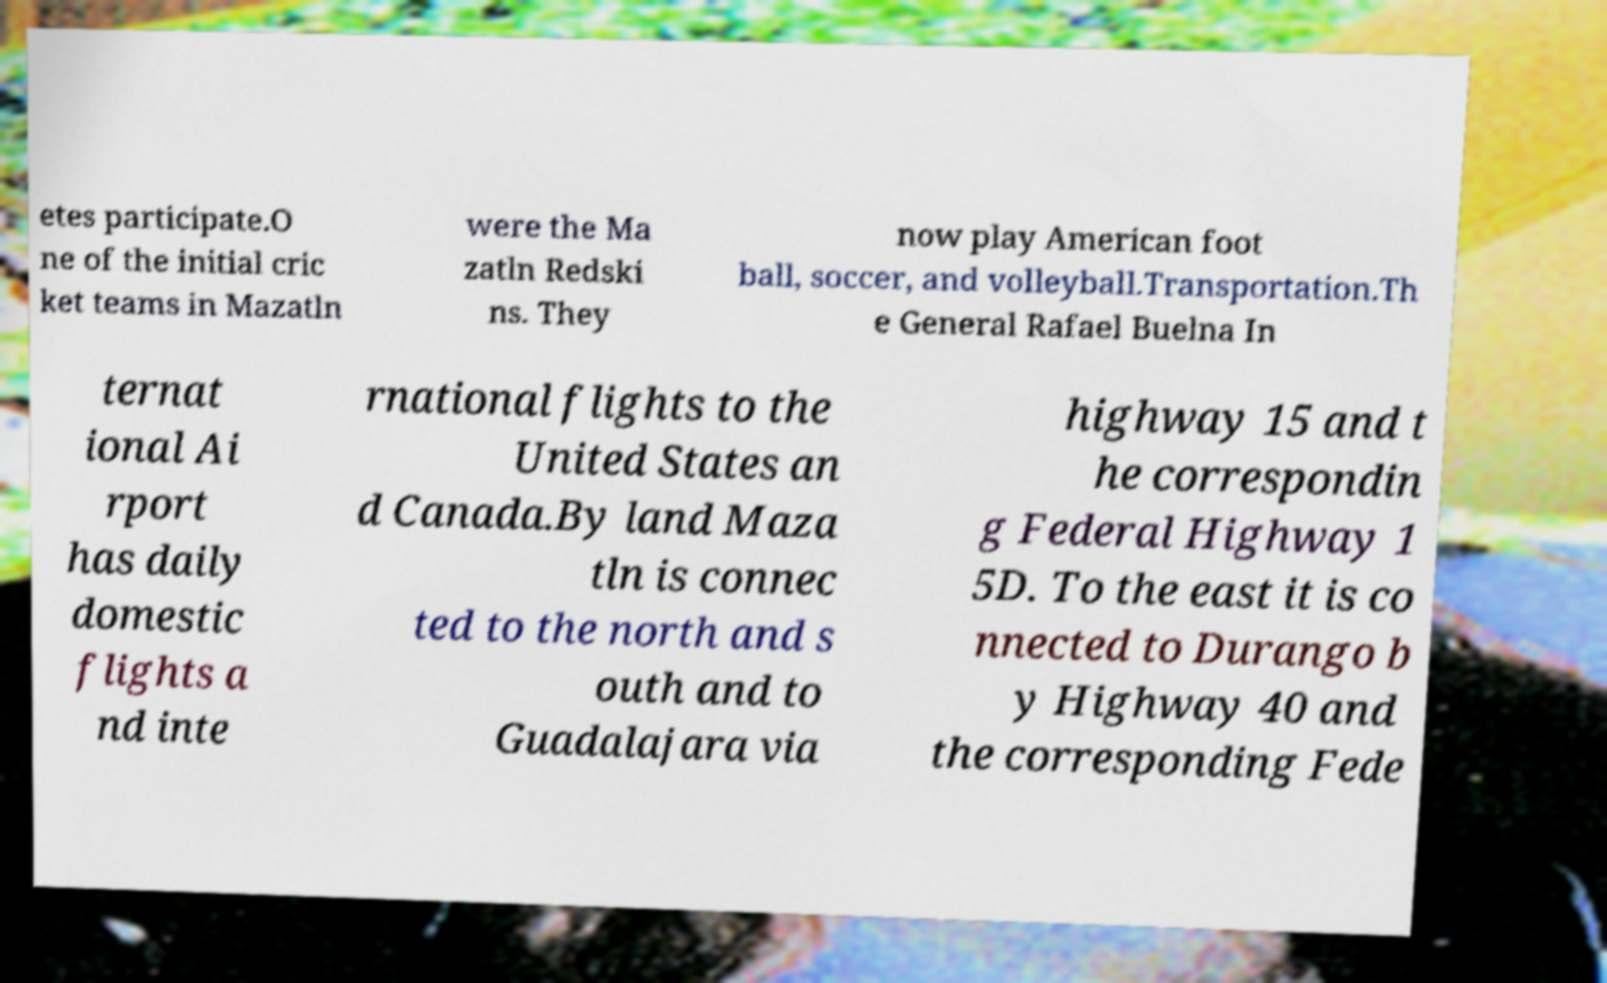Can you read and provide the text displayed in the image?This photo seems to have some interesting text. Can you extract and type it out for me? etes participate.O ne of the initial cric ket teams in Mazatln were the Ma zatln Redski ns. They now play American foot ball, soccer, and volleyball.Transportation.Th e General Rafael Buelna In ternat ional Ai rport has daily domestic flights a nd inte rnational flights to the United States an d Canada.By land Maza tln is connec ted to the north and s outh and to Guadalajara via highway 15 and t he correspondin g Federal Highway 1 5D. To the east it is co nnected to Durango b y Highway 40 and the corresponding Fede 